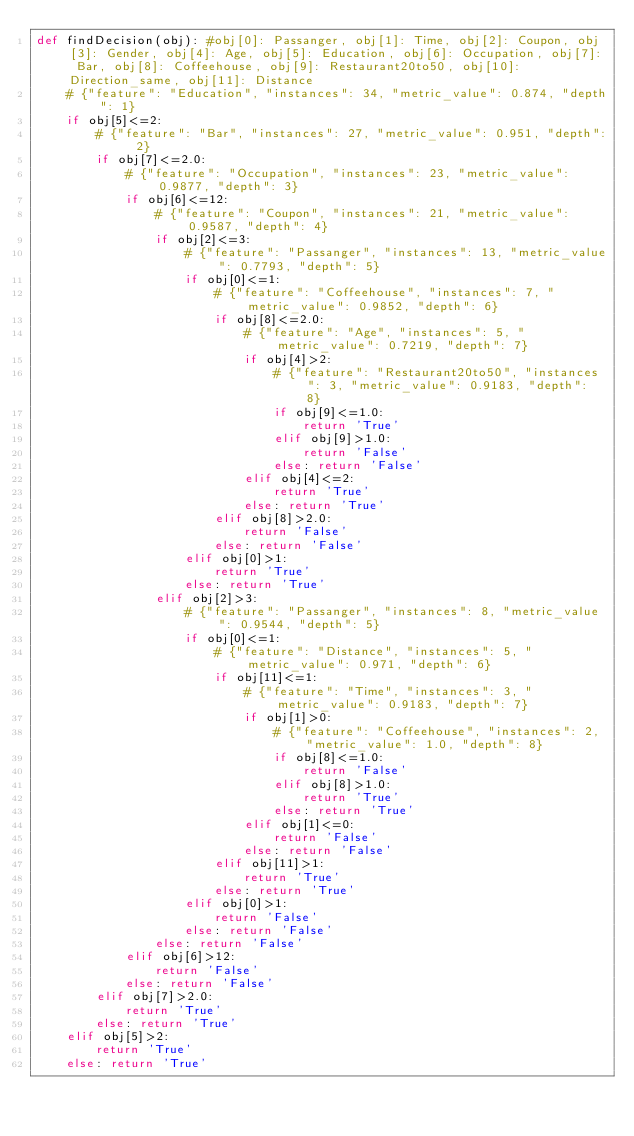Convert code to text. <code><loc_0><loc_0><loc_500><loc_500><_Python_>def findDecision(obj): #obj[0]: Passanger, obj[1]: Time, obj[2]: Coupon, obj[3]: Gender, obj[4]: Age, obj[5]: Education, obj[6]: Occupation, obj[7]: Bar, obj[8]: Coffeehouse, obj[9]: Restaurant20to50, obj[10]: Direction_same, obj[11]: Distance
	# {"feature": "Education", "instances": 34, "metric_value": 0.874, "depth": 1}
	if obj[5]<=2:
		# {"feature": "Bar", "instances": 27, "metric_value": 0.951, "depth": 2}
		if obj[7]<=2.0:
			# {"feature": "Occupation", "instances": 23, "metric_value": 0.9877, "depth": 3}
			if obj[6]<=12:
				# {"feature": "Coupon", "instances": 21, "metric_value": 0.9587, "depth": 4}
				if obj[2]<=3:
					# {"feature": "Passanger", "instances": 13, "metric_value": 0.7793, "depth": 5}
					if obj[0]<=1:
						# {"feature": "Coffeehouse", "instances": 7, "metric_value": 0.9852, "depth": 6}
						if obj[8]<=2.0:
							# {"feature": "Age", "instances": 5, "metric_value": 0.7219, "depth": 7}
							if obj[4]>2:
								# {"feature": "Restaurant20to50", "instances": 3, "metric_value": 0.9183, "depth": 8}
								if obj[9]<=1.0:
									return 'True'
								elif obj[9]>1.0:
									return 'False'
								else: return 'False'
							elif obj[4]<=2:
								return 'True'
							else: return 'True'
						elif obj[8]>2.0:
							return 'False'
						else: return 'False'
					elif obj[0]>1:
						return 'True'
					else: return 'True'
				elif obj[2]>3:
					# {"feature": "Passanger", "instances": 8, "metric_value": 0.9544, "depth": 5}
					if obj[0]<=1:
						# {"feature": "Distance", "instances": 5, "metric_value": 0.971, "depth": 6}
						if obj[11]<=1:
							# {"feature": "Time", "instances": 3, "metric_value": 0.9183, "depth": 7}
							if obj[1]>0:
								# {"feature": "Coffeehouse", "instances": 2, "metric_value": 1.0, "depth": 8}
								if obj[8]<=1.0:
									return 'False'
								elif obj[8]>1.0:
									return 'True'
								else: return 'True'
							elif obj[1]<=0:
								return 'False'
							else: return 'False'
						elif obj[11]>1:
							return 'True'
						else: return 'True'
					elif obj[0]>1:
						return 'False'
					else: return 'False'
				else: return 'False'
			elif obj[6]>12:
				return 'False'
			else: return 'False'
		elif obj[7]>2.0:
			return 'True'
		else: return 'True'
	elif obj[5]>2:
		return 'True'
	else: return 'True'
</code> 